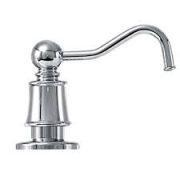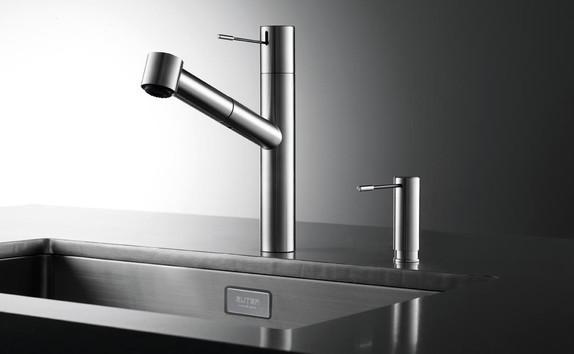The first image is the image on the left, the second image is the image on the right. Assess this claim about the two images: "A built-in soap dispenser is next to a faucet in at least one of the images.". Correct or not? Answer yes or no. Yes. The first image is the image on the left, the second image is the image on the right. Examine the images to the left and right. Is the description "An image includes a single chrome spout that curves downward." accurate? Answer yes or no. Yes. 